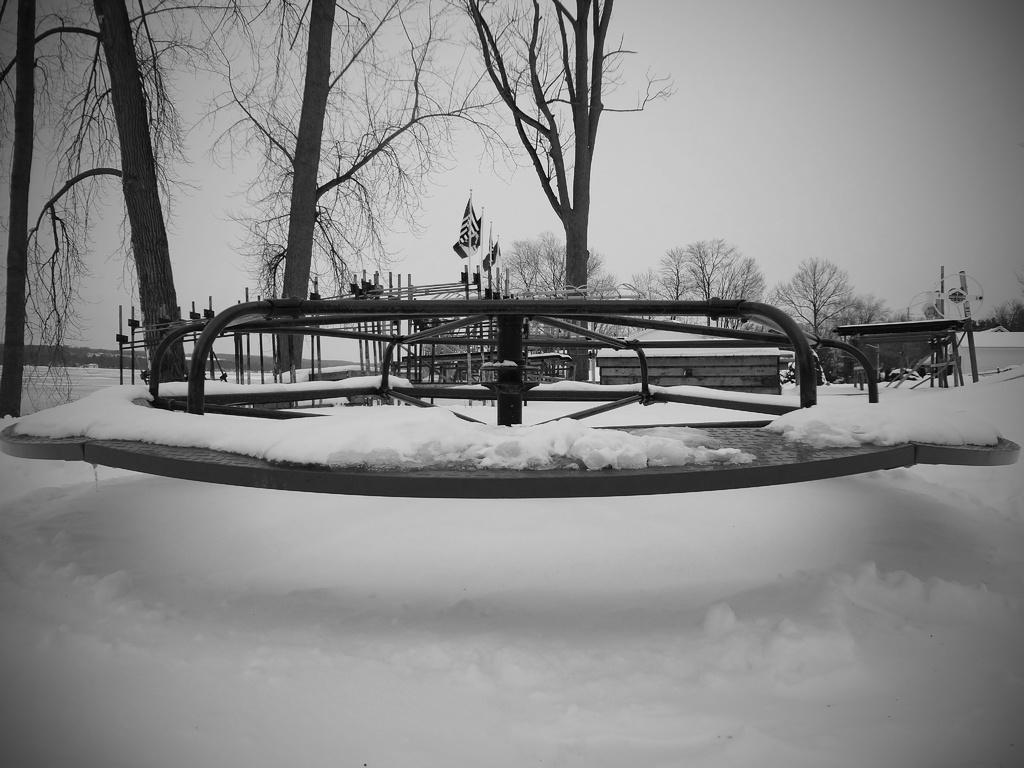What type of weather is depicted in the image? The image shows snow at the bottom, indicating a winter scene. What type of vegetation can be seen in the image? There are trees in the image. What is visible at the top of the image? The sky is visible at the top of the image. What is the color scheme of the image? The image is black and white. Is there a lawyer standing next to the trees in the image? There is no lawyer present in the image; it only features snow, trees, and a black and white color scheme. 